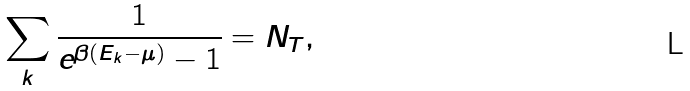Convert formula to latex. <formula><loc_0><loc_0><loc_500><loc_500>\sum _ { k } \frac { 1 } { e ^ { \beta ( E _ { k } - \mu ) } - 1 } = N _ { T } ,</formula> 